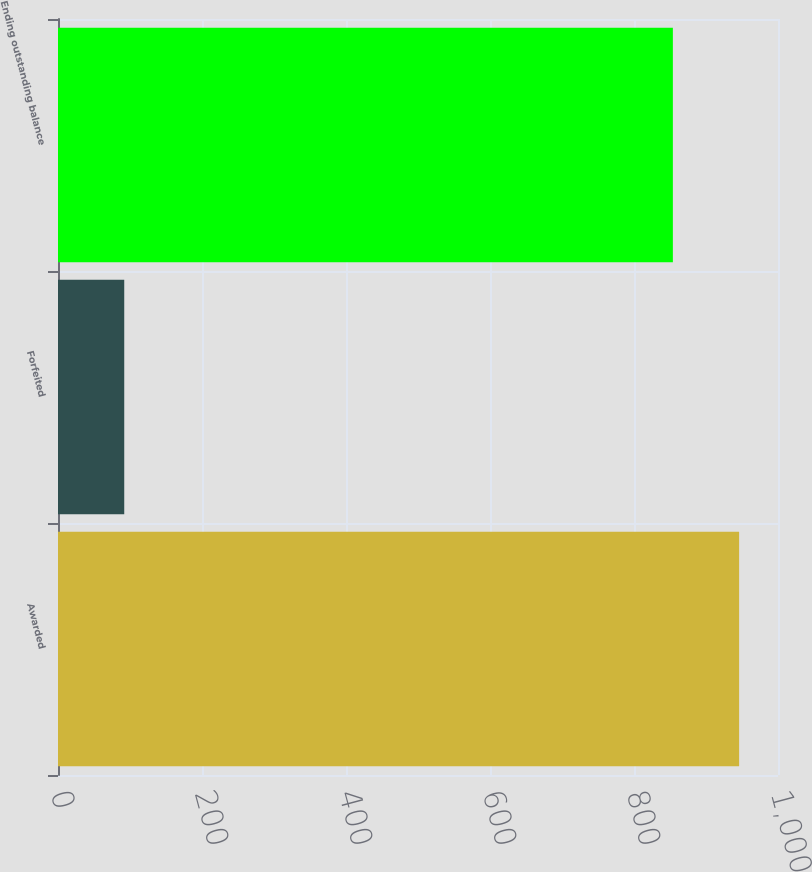Convert chart. <chart><loc_0><loc_0><loc_500><loc_500><bar_chart><fcel>Awarded<fcel>Forfeited<fcel>Ending outstanding balance<nl><fcel>946<fcel>92<fcel>854<nl></chart> 